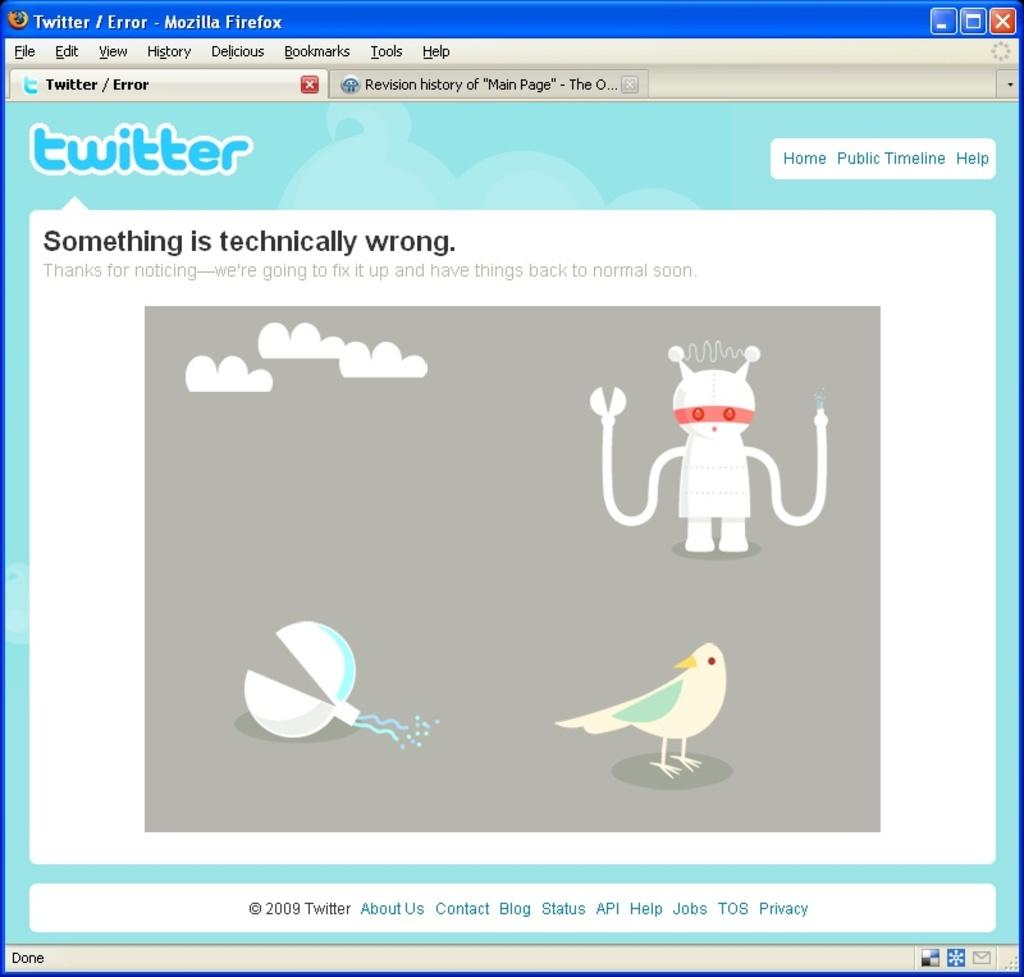What type of content is displayed in the image? The image is of a web page. What can be seen on the web page besides text? There are images on the web page. What type of information is provided on the web page? There is text on the web page. How many slaves are visible on the web page? There are no slaves present on the web page; it contains images and text. 